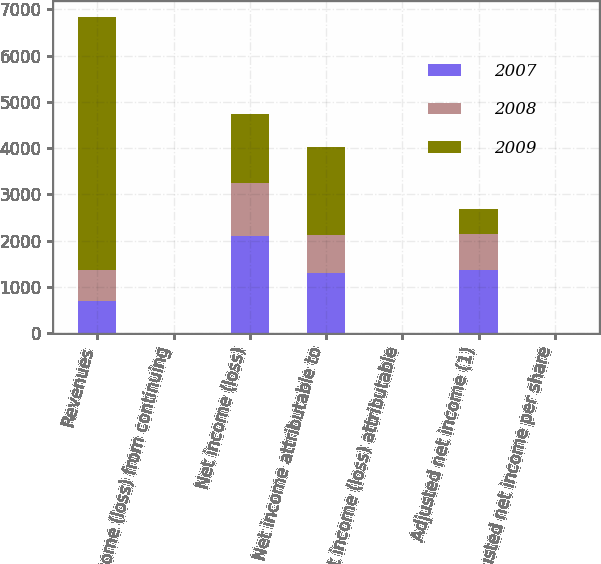<chart> <loc_0><loc_0><loc_500><loc_500><stacked_bar_chart><ecel><fcel>Revenues<fcel>Income (loss) from continuing<fcel>Net income (loss)<fcel>Net income attributable to<fcel>Net income (loss) attributable<fcel>Adjusted net income (1)<fcel>Adjusted net income per share<nl><fcel>2007<fcel>686<fcel>2.68<fcel>2093<fcel>1297<fcel>2.66<fcel>1359<fcel>2.79<nl><fcel>2008<fcel>686<fcel>1.8<fcel>1160<fcel>831<fcel>1.83<fcel>792<fcel>1.74<nl><fcel>2009<fcel>5465<fcel>2.18<fcel>1485<fcel>1895<fcel>4.19<fcel>524<fcel>1.16<nl></chart> 